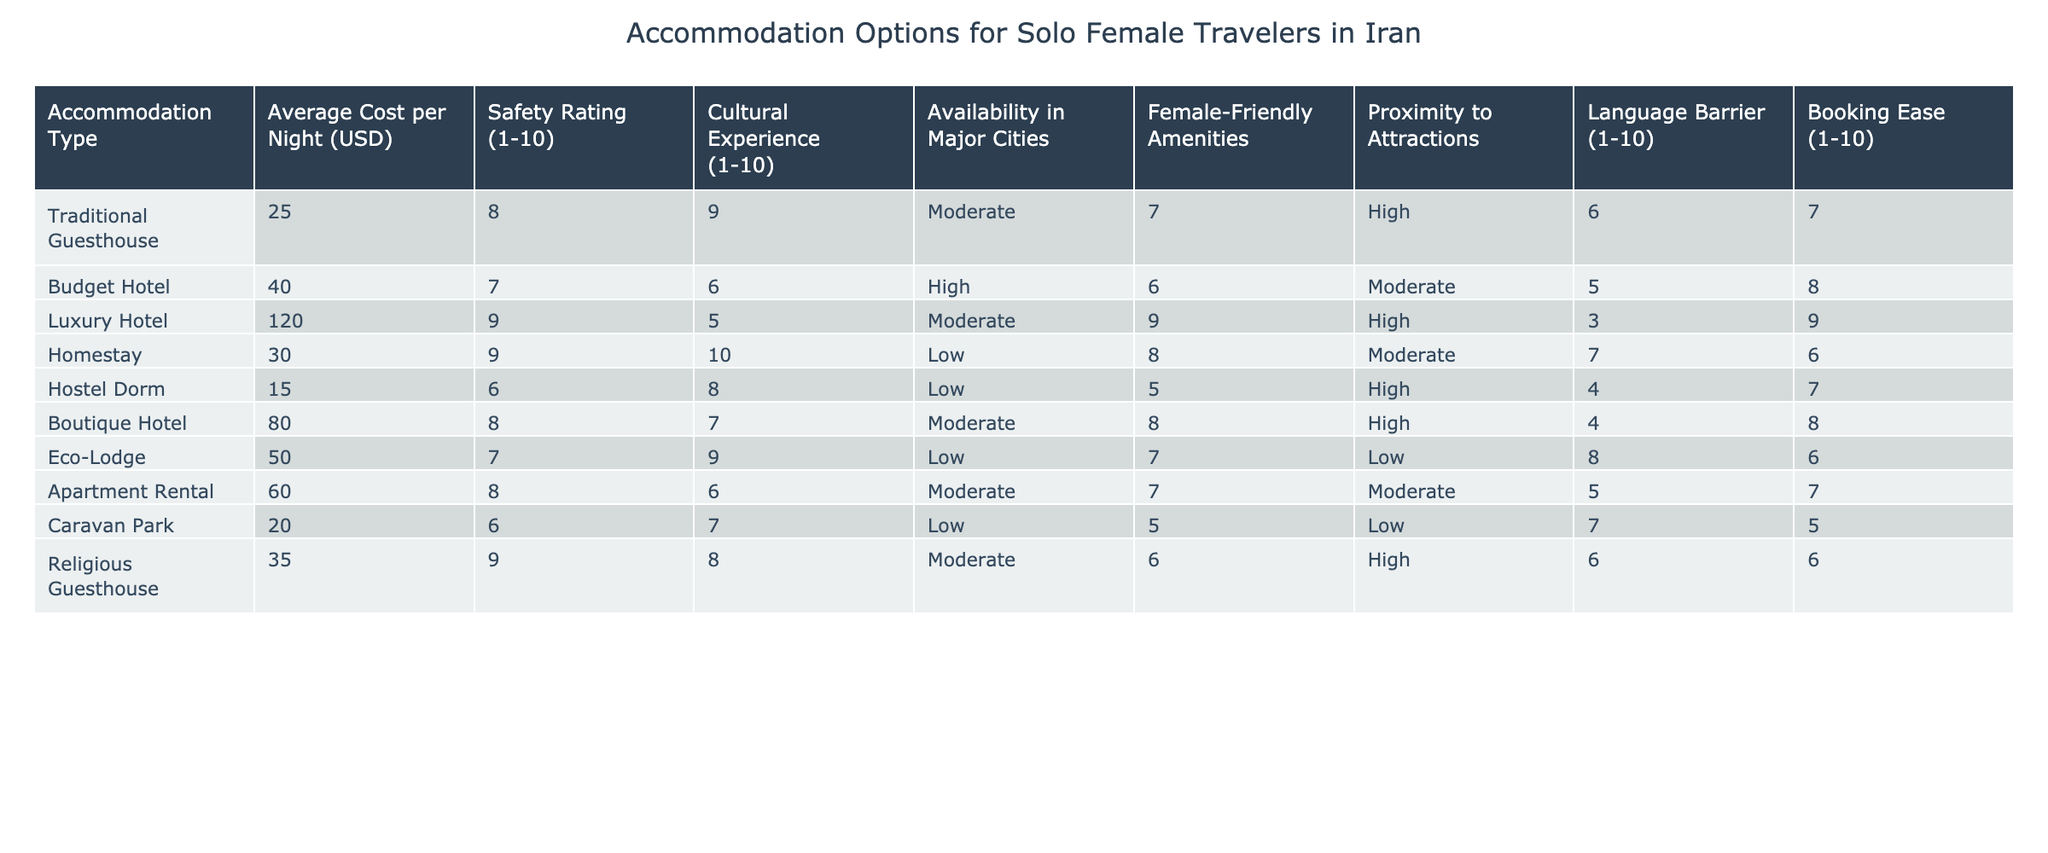What is the average cost per night for a Traditional Guesthouse? The table shows that the average cost per night for a Traditional Guesthouse is listed as 25 USD.
Answer: 25 USD Which accommodation type has the highest safety rating? The highest safety rating in the table is 9, which is associated with both Luxury Hotels and Religious Guesthouses.
Answer: Luxury Hotel and Religious Guesthouse What is the average safety rating for all accommodations in the table? To find the average safety rating, add all the safety ratings: (8 + 7 + 9 + 9 + 6 + 8 + 7 + 8 + 6 + 9) = 77. There are 10 types of accommodation, so the average safety rating is 77 / 10 = 7.7.
Answer: 7.7 Is the language barrier higher in Budget Hotels or in Hostels? The table indicates a language barrier rating of 5 for Budget Hotels and 4 for Hostels. Since 5 is greater than 4, the language barrier is higher in Budget Hotels.
Answer: Yes Which accommodation types provide female-friendly amenities rated 9 or higher? From the table, the only accommodation providing a female-friendly amenities rating of 9 is Luxury Hotel.
Answer: Luxury Hotel How does the average cost for Homestays and Eco-Lodges compare? The average cost for Homestays is 30 USD, while Eco-Lodges cost 50 USD. The cost for Eco-Lodges exceeds that of Homestays by 20 USD.
Answer: Eco-Lodges are 20 USD more expensive Which accommodation type has both high cultural experience and safety rating? Traditional Guesthouses have a cultural experience rating of 9 and a safety rating of 8, making them the only accommodation type with high ratings in both categories.
Answer: Traditional Guesthouse If you want a highly rated accommodation that is easy to book, which should you choose? Looking at the table, Luxury Hotels have a booking ease rating of 9 and a safety rating of 9 but a high cost. Budget Hotels, however, have an 8 for booking ease, with a lower cost. Hence, for balance, Budget Hotels would be the recommended choice.
Answer: Budget Hotel What is the booking ease rating difference between Traditional Guesthouses and Hostels? The booking ease for Traditional Guesthouses is 7, while for Hostels it is also 7. Therefore, the difference is 0, meaning both have the same booking ease.
Answer: 0 Does every accommodation type have female-friendly amenities? Upon checking the table, about half of the accommodation types listed have female-friendly amenities, but it is not true that all types have them. Specifically, Caravan Parks and Hostels have lower ratings.
Answer: No 